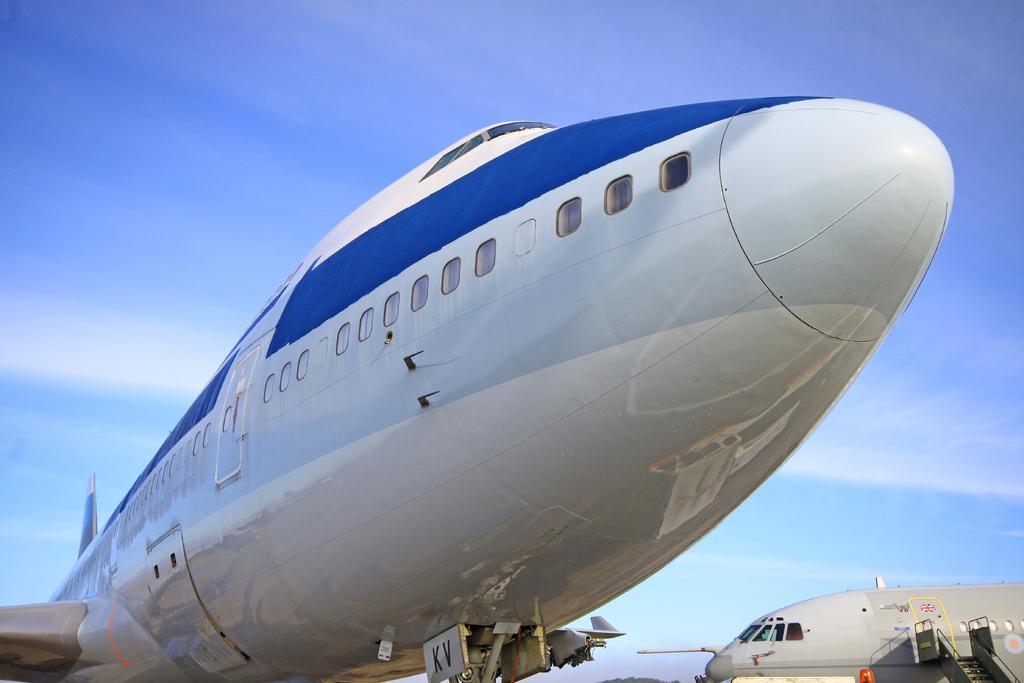How would you summarize this image in a sentence or two? In this picture I can see the two passenger planes. In the bottom right corner I can see the ladder near to the plane's door. At the top I can see the sky and clouds. In the center I can see the plane's windows and door. 